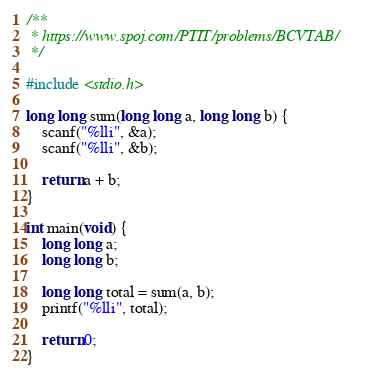Convert code to text. <code><loc_0><loc_0><loc_500><loc_500><_C_>/**
 * https://www.spoj.com/PTIT/problems/BCVTAB/
 */

#include <stdio.h>
    
long long sum(long long a, long long b) {
    scanf("%lli", &a);
    scanf("%lli", &b);
    
    return a + b;
}
    
int main(void) {
    long long a;
    long long b;
    
    long long total = sum(a, b);
    printf("%lli", total);
    
    return 0;
}
</code> 